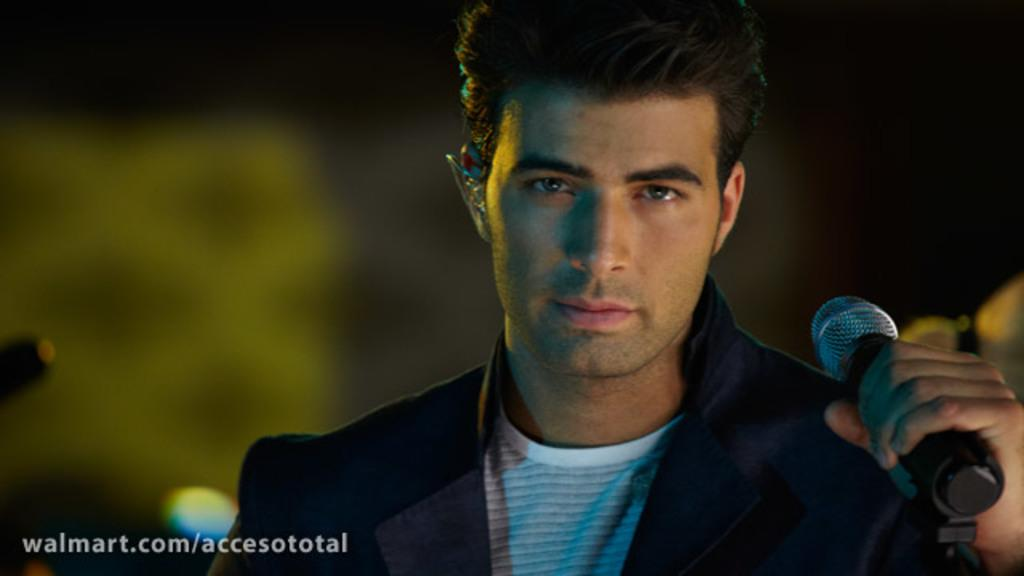Who is the main subject in the image? There is a man in the image. What is the man doing in the image? The man is posing for the camera. What object is the man holding in his hand? The man is holding a microphone in his hand. What type of bread is the man using as a prop in the image? There is no bread present in the image; the man is holding a microphone. What type of judge is depicted in the image? There is no judge depicted in the image; the main subject is a man holding a microphone. 